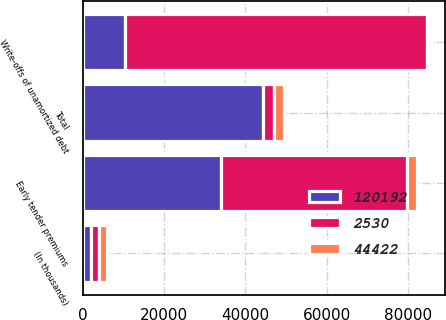Convert chart. <chart><loc_0><loc_0><loc_500><loc_500><stacked_bar_chart><ecel><fcel>(In thousands)<fcel>Early tender premiums<fcel>Write-offs of unamortized debt<fcel>Total<nl><fcel>44422<fcel>2015<fcel>2395<fcel>135<fcel>2530<nl><fcel>120192<fcel>2014<fcel>33971<fcel>10451<fcel>44422<nl><fcel>2530<fcel>2013<fcel>45812<fcel>74380<fcel>2530<nl></chart> 